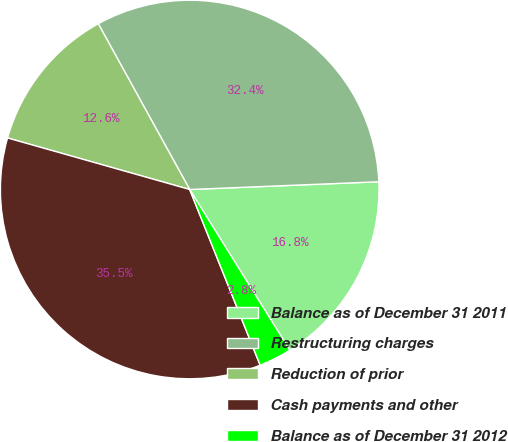<chart> <loc_0><loc_0><loc_500><loc_500><pie_chart><fcel>Balance as of December 31 2011<fcel>Restructuring charges<fcel>Reduction of prior<fcel>Cash payments and other<fcel>Balance as of December 31 2012<nl><fcel>16.78%<fcel>32.37%<fcel>12.59%<fcel>35.46%<fcel>2.8%<nl></chart> 